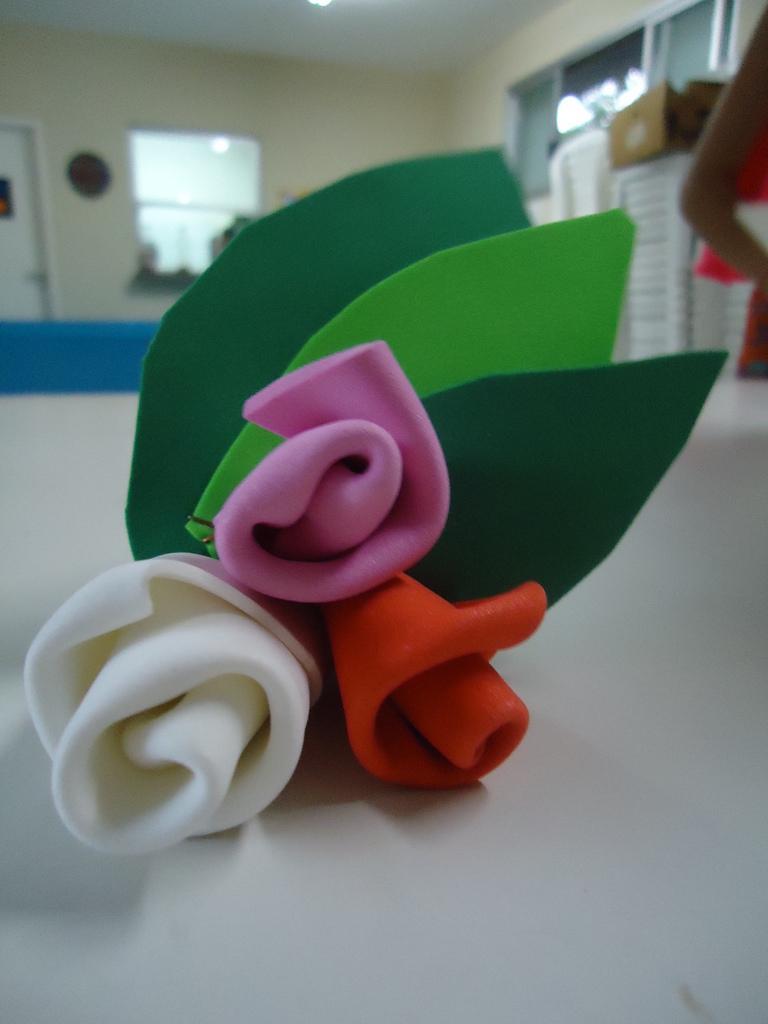In one or two sentences, can you explain what this image depicts? In the center of the image we can see the flowers and leaves which are made with foam sheet are present on the surface. In the background of the image we can see the wall, door, windows, board, chairs, box and a person. At the top of the image we can see the floor and light. 